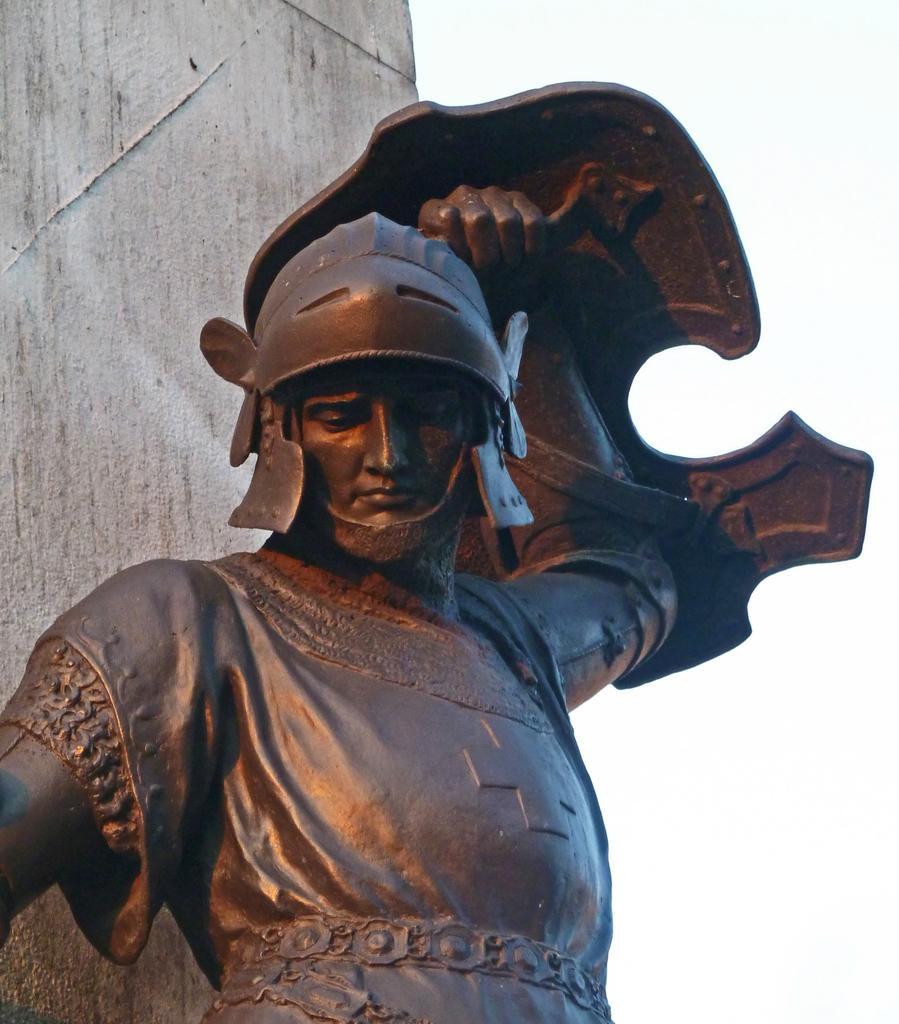Please provide a concise description of this image. In this picture in the front there is a statue. In the background there is a wall. 